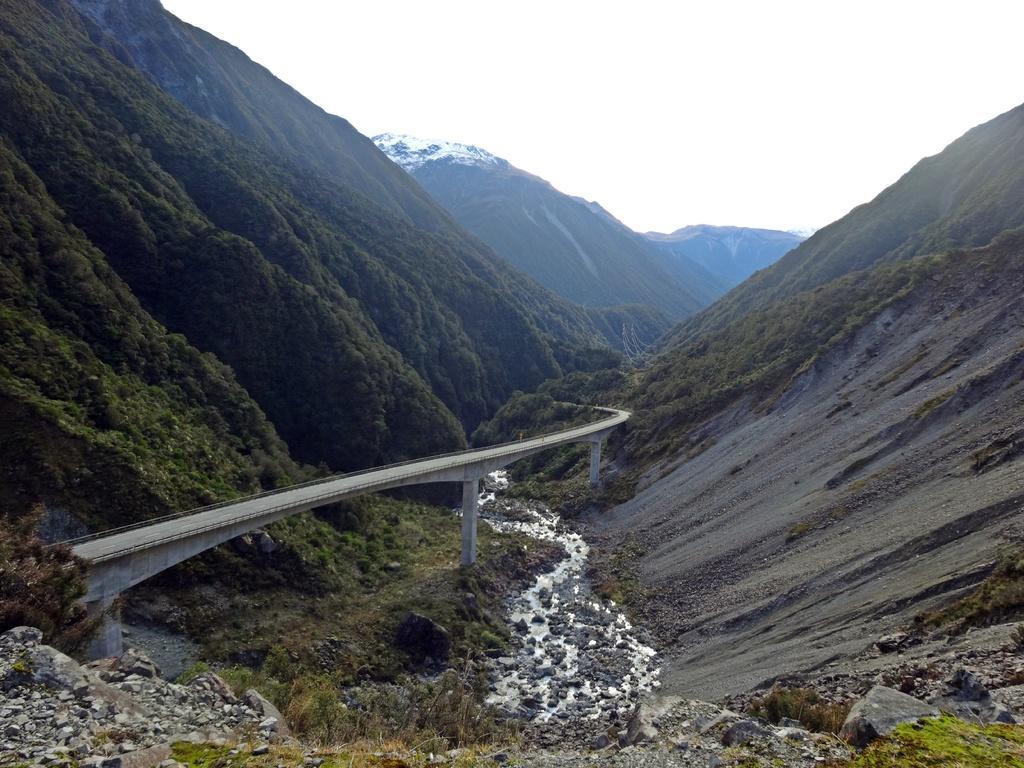Can you describe this image briefly? In this image we can see sky, hills, bridge, pillars, rocks, flowing water, plants and grass. 